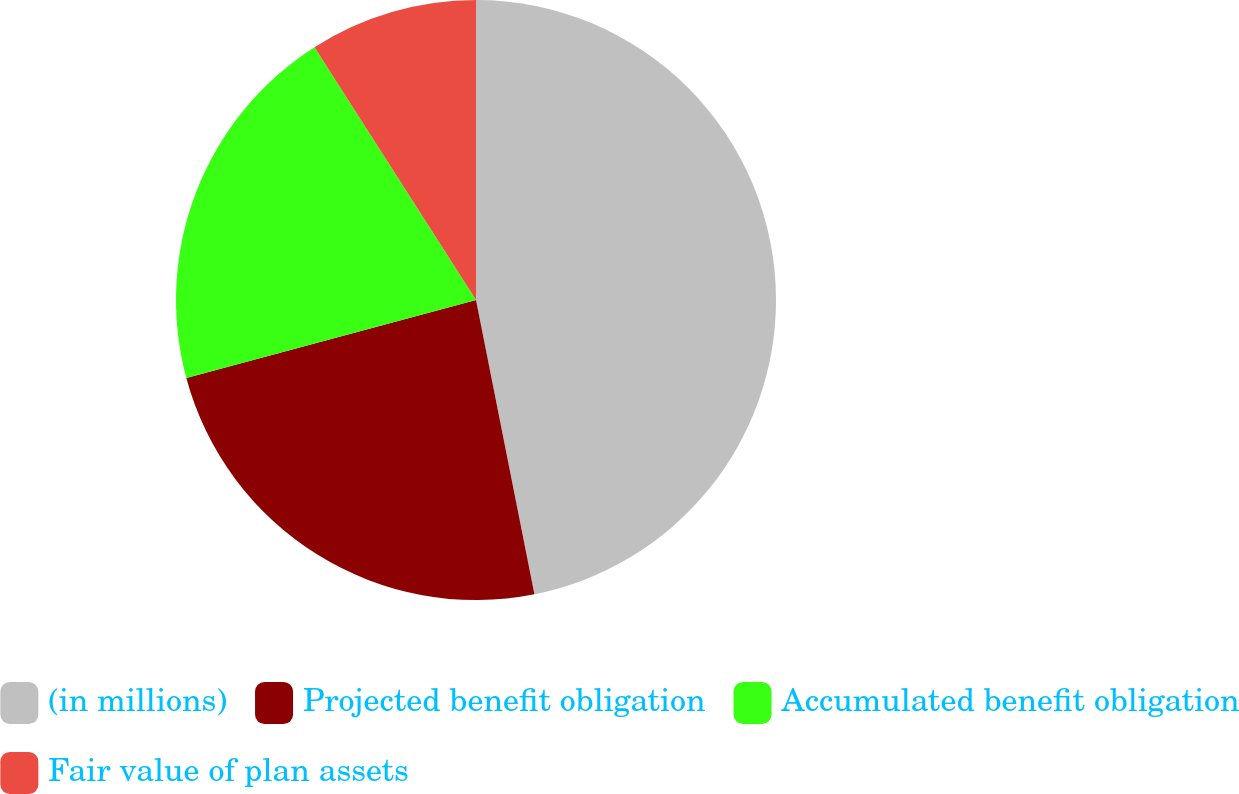<chart> <loc_0><loc_0><loc_500><loc_500><pie_chart><fcel>(in millions)<fcel>Projected benefit obligation<fcel>Accumulated benefit obligation<fcel>Fair value of plan assets<nl><fcel>46.88%<fcel>23.93%<fcel>20.14%<fcel>9.05%<nl></chart> 